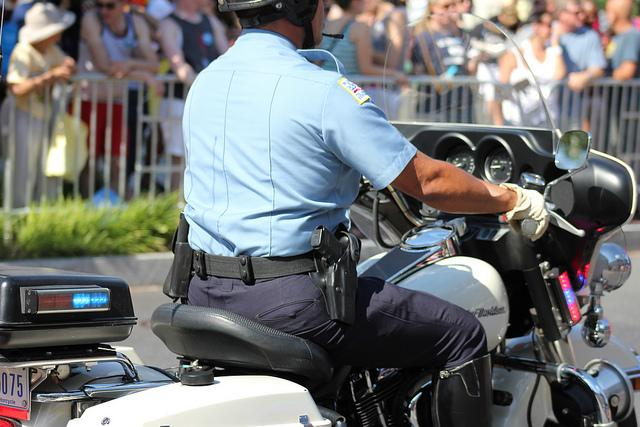What part of the cops uniform has the most similar theme to the motorcycle? Please explain your reasoning. gloves. The gloves are similar. 